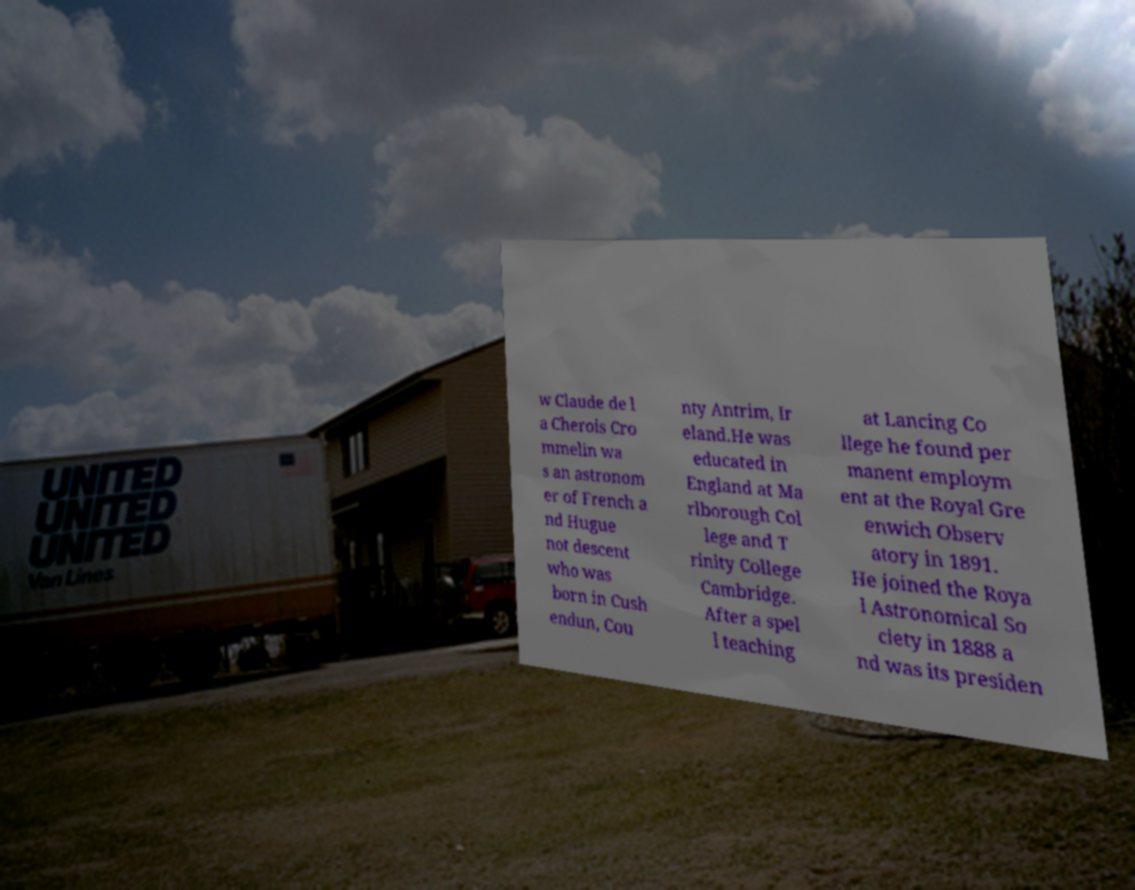I need the written content from this picture converted into text. Can you do that? w Claude de l a Cherois Cro mmelin wa s an astronom er of French a nd Hugue not descent who was born in Cush endun, Cou nty Antrim, Ir eland.He was educated in England at Ma rlborough Col lege and T rinity College Cambridge. After a spel l teaching at Lancing Co llege he found per manent employm ent at the Royal Gre enwich Observ atory in 1891. He joined the Roya l Astronomical So ciety in 1888 a nd was its presiden 